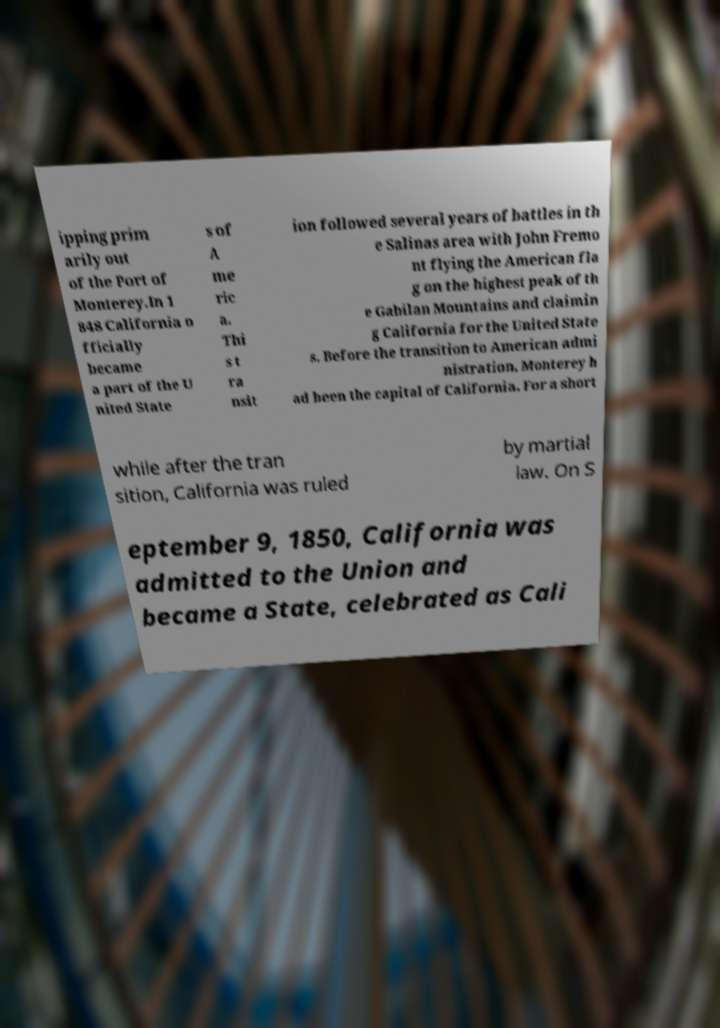Could you extract and type out the text from this image? ipping prim arily out of the Port of Monterey.In 1 848 California o fficially became a part of the U nited State s of A me ric a. Thi s t ra nsit ion followed several years of battles in th e Salinas area with John Fremo nt flying the American fla g on the highest peak of th e Gabilan Mountains and claimin g California for the United State s. Before the transition to American admi nistration, Monterey h ad been the capital of California. For a short while after the tran sition, California was ruled by martial law. On S eptember 9, 1850, California was admitted to the Union and became a State, celebrated as Cali 